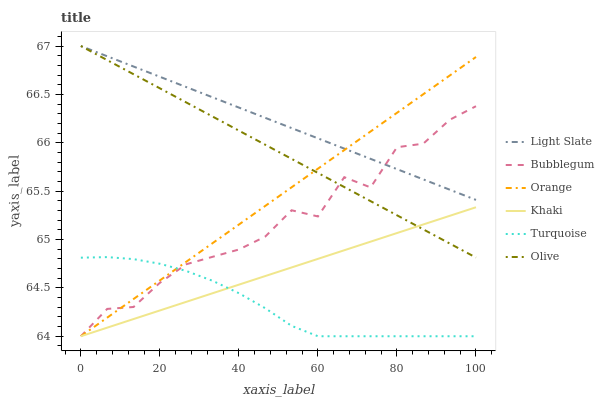Does Turquoise have the minimum area under the curve?
Answer yes or no. Yes. Does Khaki have the minimum area under the curve?
Answer yes or no. No. Does Khaki have the maximum area under the curve?
Answer yes or no. No. Is Khaki the smoothest?
Answer yes or no. No. Is Khaki the roughest?
Answer yes or no. No. Does Light Slate have the lowest value?
Answer yes or no. No. Does Khaki have the highest value?
Answer yes or no. No. Is Turquoise less than Olive?
Answer yes or no. Yes. Is Light Slate greater than Khaki?
Answer yes or no. Yes. Does Turquoise intersect Olive?
Answer yes or no. No. 